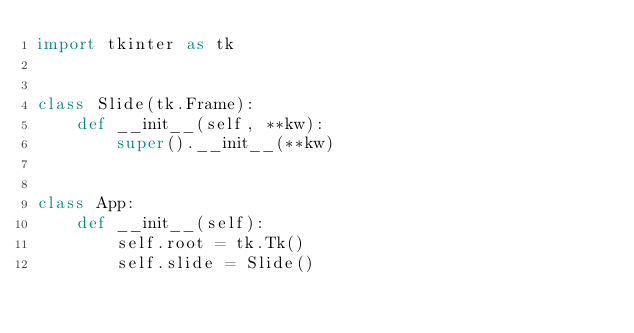Convert code to text. <code><loc_0><loc_0><loc_500><loc_500><_Python_>import tkinter as tk


class Slide(tk.Frame):
    def __init__(self, **kw):
        super().__init__(**kw)


class App:
    def __init__(self):
        self.root = tk.Tk()
        self.slide = Slide()
</code> 